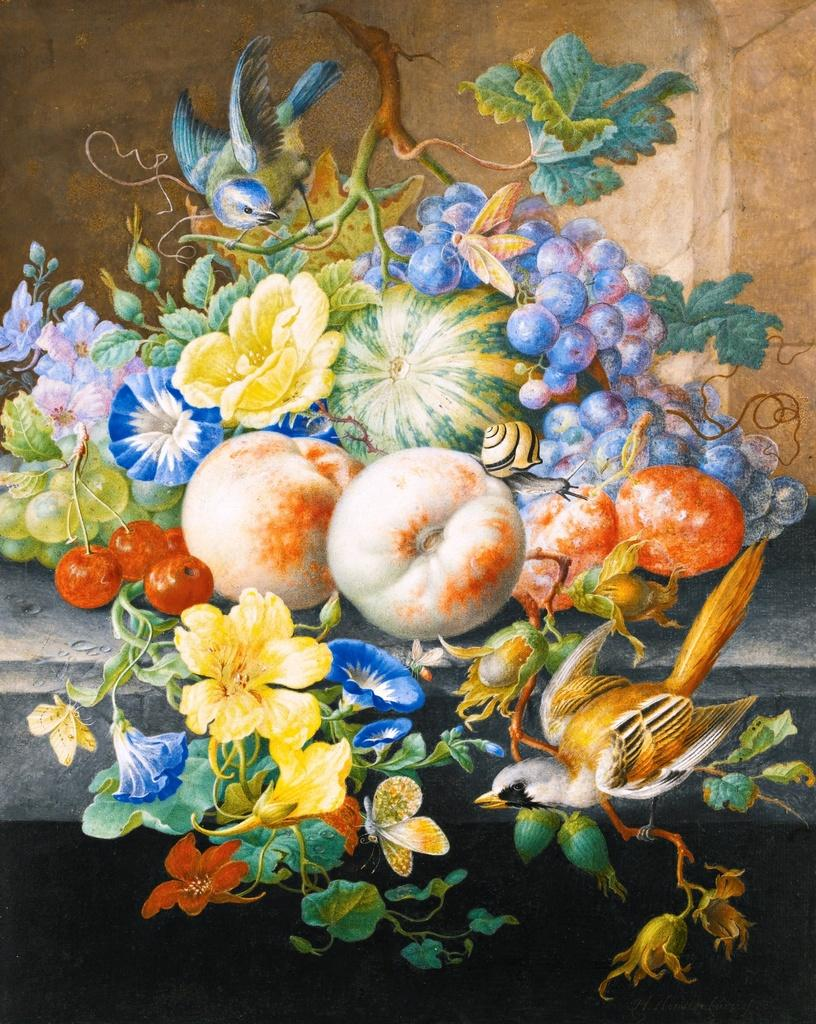What is the main subject of the image? The image contains an art piece. What types of objects are depicted in the art? Fruits, flowers, a creeper, and birds are depicted in the art. Is there a locket hanging from the tree in the image? There is no tree present in the image, and therefore no locket hanging from it. 